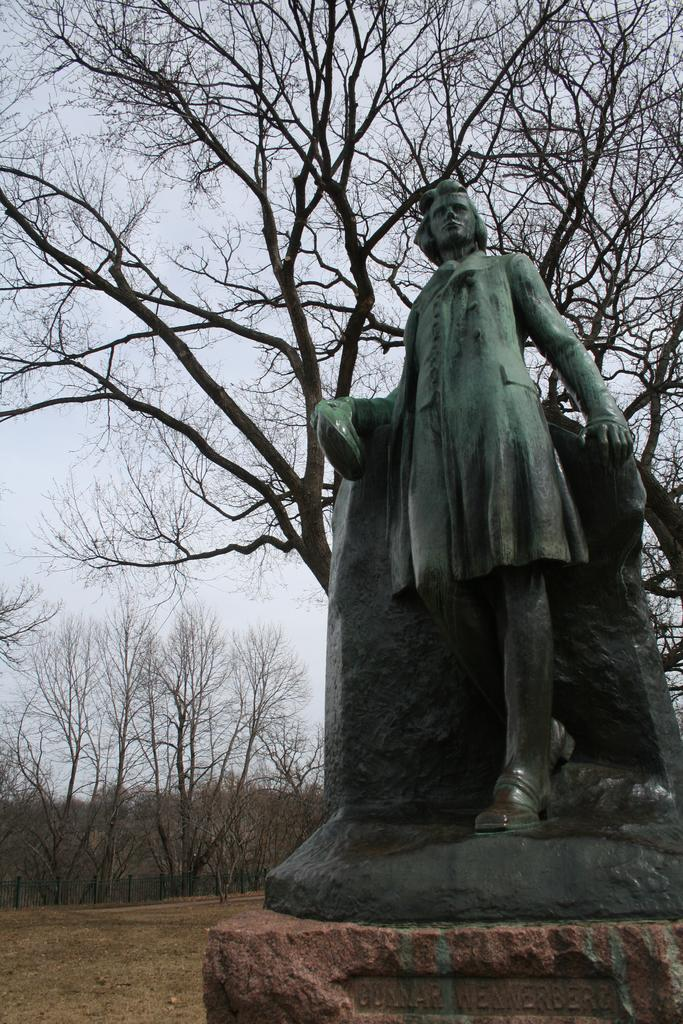What is located in the center of the image? There is a stone and a statue in the center of the image. What is the color of the statue? The statue is green in color. What can be seen in the background of the image? There is sky, clouds, and trees visible in the background of the image. How many bikes are leaning against the statue in the image? There are no bikes present in the image. 